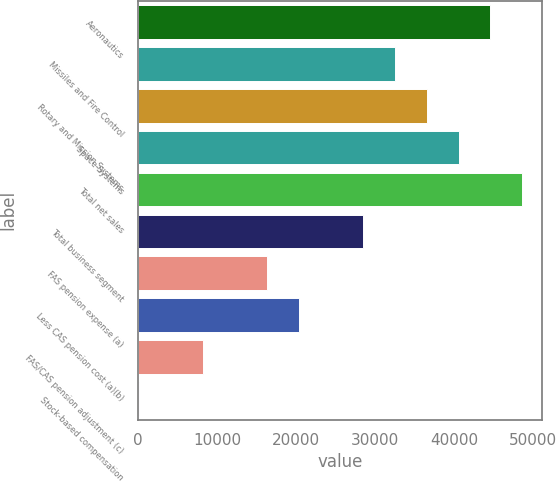Convert chart to OTSL. <chart><loc_0><loc_0><loc_500><loc_500><bar_chart><fcel>Aeronautics<fcel>Missiles and Fire Control<fcel>Rotary and Mission Systems<fcel>Space Systems<fcel>Total net sales<fcel>Total business segment<fcel>FAS pension expense (a)<fcel>Less CAS pension cost (a)(b)<fcel>FAS/CAS pension adjustment (c)<fcel>Stock-based compensation<nl><fcel>44576.3<fcel>32455.4<fcel>36495.7<fcel>40536<fcel>48616.6<fcel>28415.1<fcel>16294.2<fcel>20334.5<fcel>8213.6<fcel>133<nl></chart> 